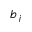Convert formula to latex. <formula><loc_0><loc_0><loc_500><loc_500>b _ { j }</formula> 